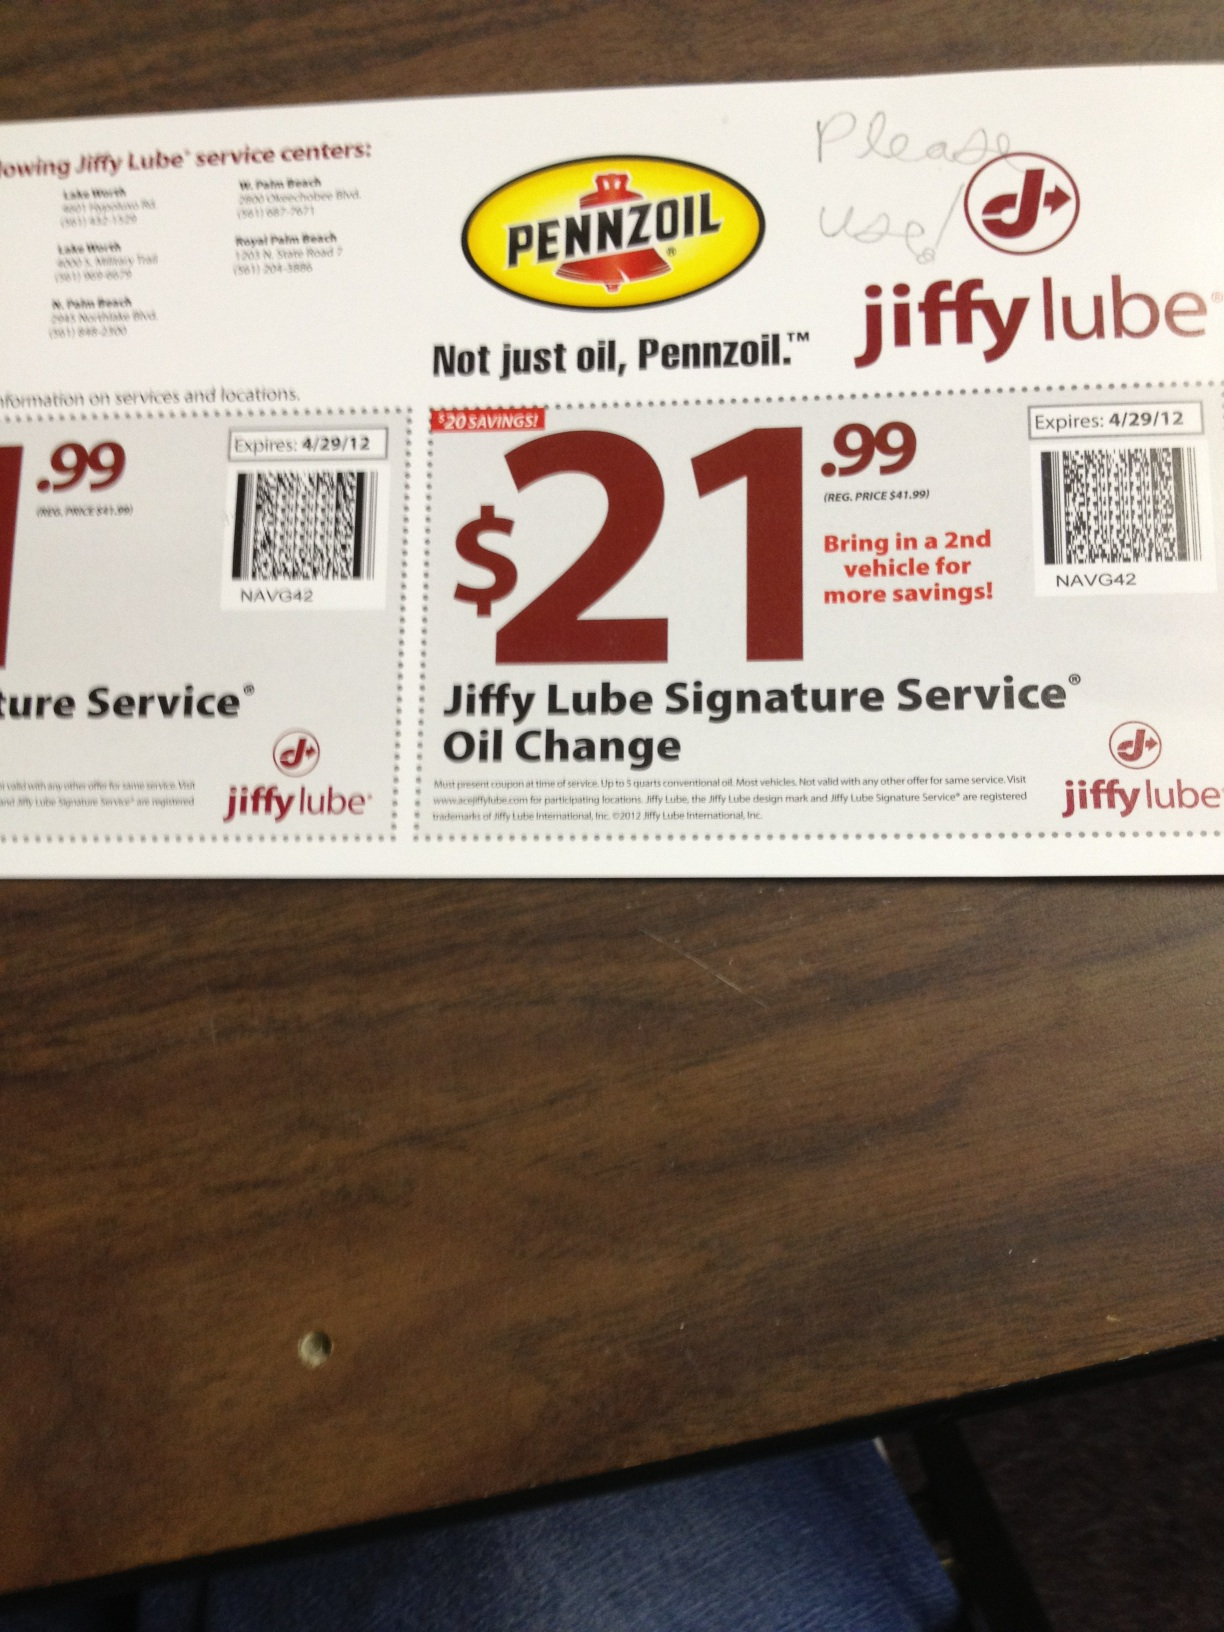How much savings does this coupon offer for an oil change service? This coupon offers a $20 saving for the Jiffy Lube Signature Service Oil Change, reducing the price from $41.99 to $21.99. 